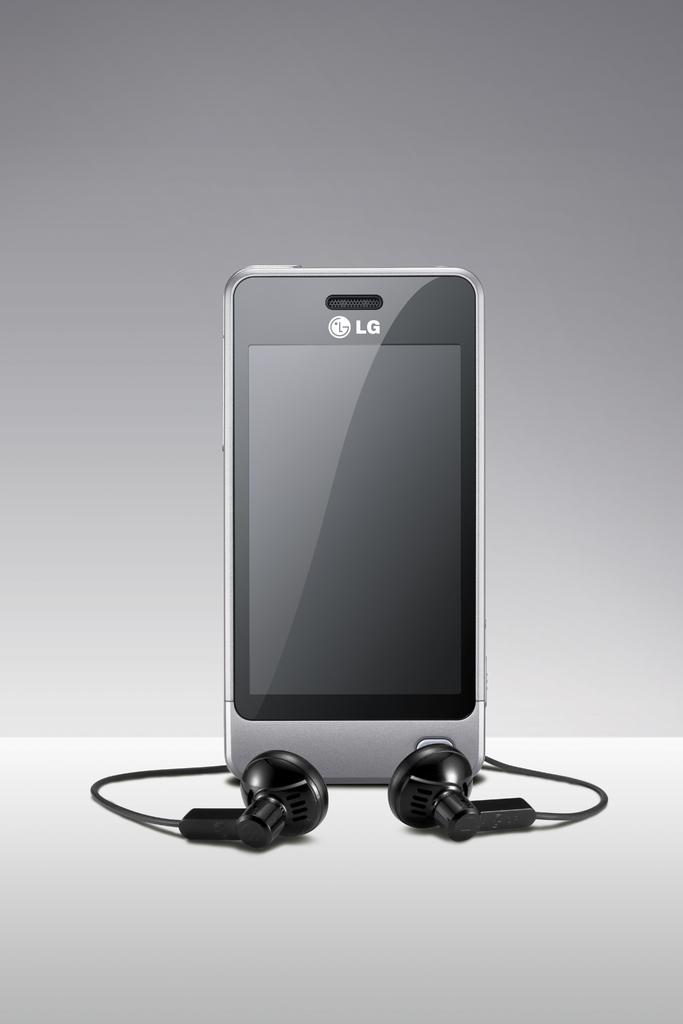<image>
Share a concise interpretation of the image provided. A silver LG phone sits with a pair of wired earbuds. 